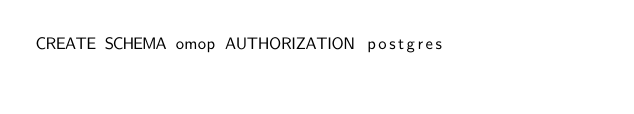<code> <loc_0><loc_0><loc_500><loc_500><_SQL_>CREATE SCHEMA omop AUTHORIZATION postgres
</code> 